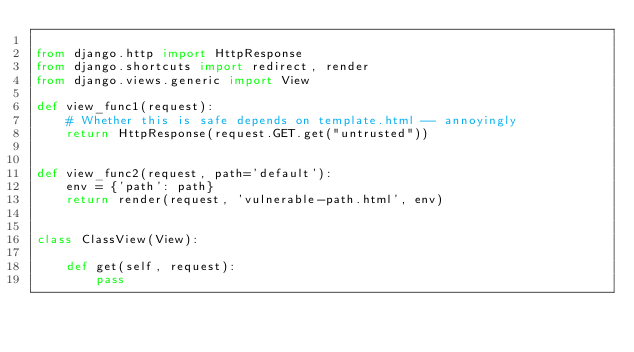Convert code to text. <code><loc_0><loc_0><loc_500><loc_500><_Python_>
from django.http import HttpResponse
from django.shortcuts import redirect, render
from django.views.generic import View

def view_func1(request):
    # Whether this is safe depends on template.html -- annoyingly
    return HttpResponse(request.GET.get("untrusted"))


def view_func2(request, path='default'):
    env = {'path': path}
    return render(request, 'vulnerable-path.html', env)


class ClassView(View):

    def get(self, request):
        pass
</code> 